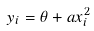<formula> <loc_0><loc_0><loc_500><loc_500>y _ { i } = \theta + a x _ { i } ^ { 2 }</formula> 